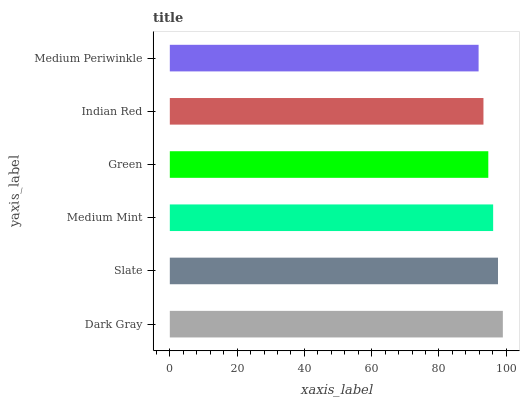Is Medium Periwinkle the minimum?
Answer yes or no. Yes. Is Dark Gray the maximum?
Answer yes or no. Yes. Is Slate the minimum?
Answer yes or no. No. Is Slate the maximum?
Answer yes or no. No. Is Dark Gray greater than Slate?
Answer yes or no. Yes. Is Slate less than Dark Gray?
Answer yes or no. Yes. Is Slate greater than Dark Gray?
Answer yes or no. No. Is Dark Gray less than Slate?
Answer yes or no. No. Is Medium Mint the high median?
Answer yes or no. Yes. Is Green the low median?
Answer yes or no. Yes. Is Indian Red the high median?
Answer yes or no. No. Is Dark Gray the low median?
Answer yes or no. No. 